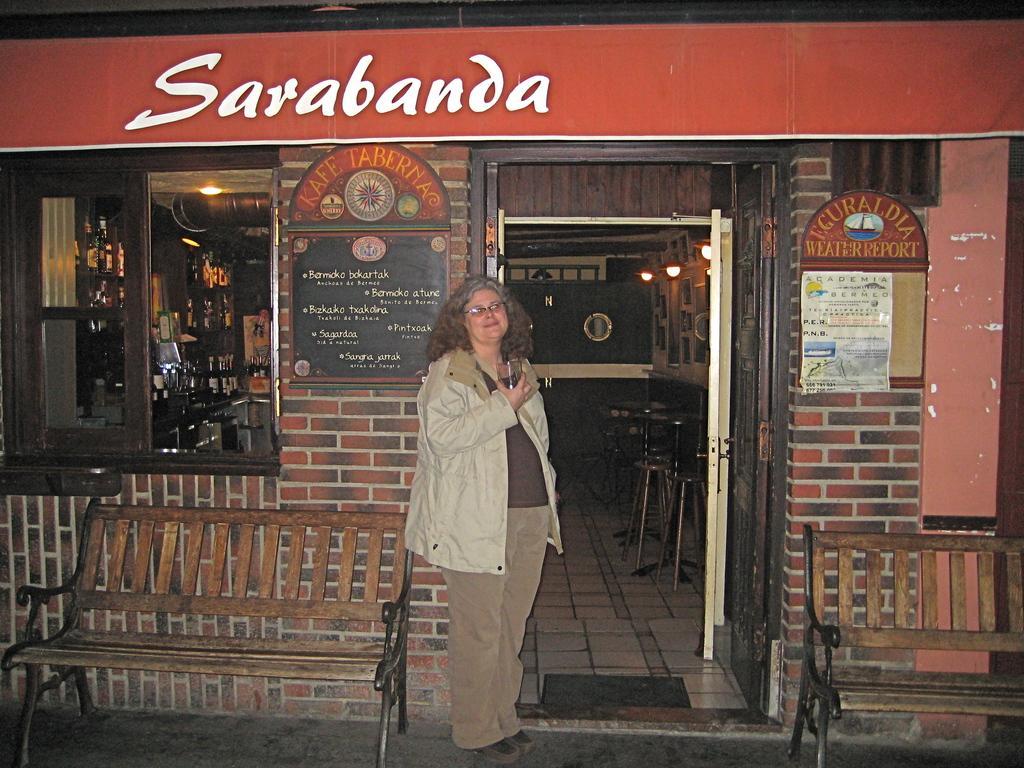Please provide a concise description of this image. In this image I can see one person is standing and holding something. I can see few benches, lights, stools, tables, bottles, boards and few objects around. 